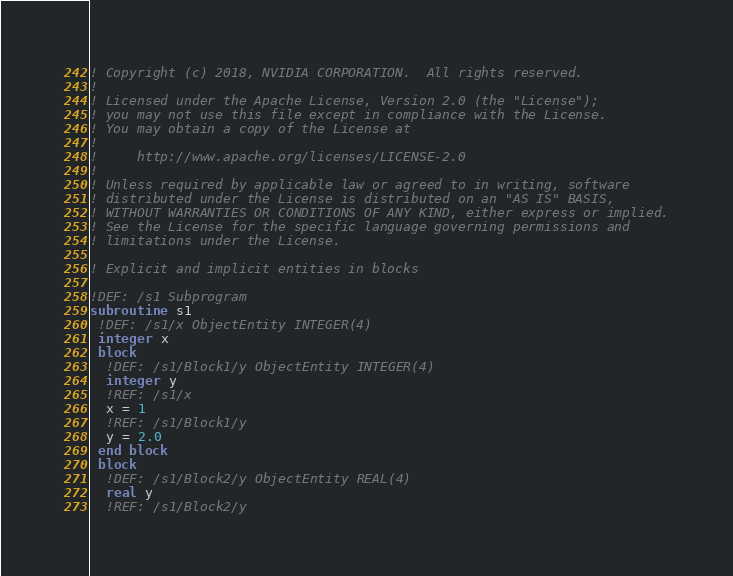Convert code to text. <code><loc_0><loc_0><loc_500><loc_500><_FORTRAN_>! Copyright (c) 2018, NVIDIA CORPORATION.  All rights reserved.
!
! Licensed under the Apache License, Version 2.0 (the "License");
! you may not use this file except in compliance with the License.
! You may obtain a copy of the License at
!
!     http://www.apache.org/licenses/LICENSE-2.0
!
! Unless required by applicable law or agreed to in writing, software
! distributed under the License is distributed on an "AS IS" BASIS,
! WITHOUT WARRANTIES OR CONDITIONS OF ANY KIND, either express or implied.
! See the License for the specific language governing permissions and
! limitations under the License.

! Explicit and implicit entities in blocks

!DEF: /s1 Subprogram
subroutine s1
 !DEF: /s1/x ObjectEntity INTEGER(4)
 integer x
 block
  !DEF: /s1/Block1/y ObjectEntity INTEGER(4)
  integer y
  !REF: /s1/x
  x = 1
  !REF: /s1/Block1/y
  y = 2.0
 end block
 block
  !DEF: /s1/Block2/y ObjectEntity REAL(4)
  real y
  !REF: /s1/Block2/y</code> 